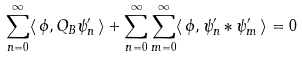Convert formula to latex. <formula><loc_0><loc_0><loc_500><loc_500>\sum _ { n = 0 } ^ { \infty } \langle \, \phi , Q _ { B } \psi ^ { \prime } _ { n } \, \rangle + \sum _ { n = 0 } ^ { \infty } \sum _ { m = 0 } ^ { \infty } \langle \, \phi , \psi ^ { \prime } _ { n } \ast \psi ^ { \prime } _ { m } \, \rangle = 0</formula> 